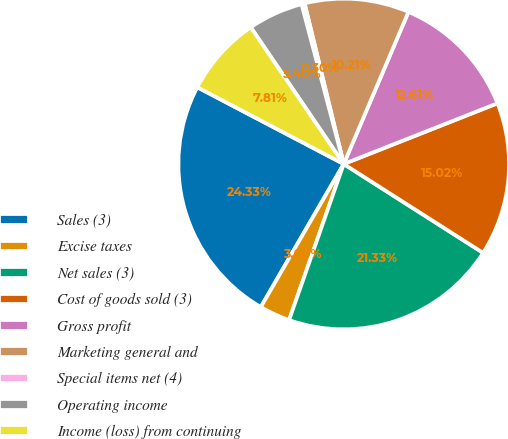<chart> <loc_0><loc_0><loc_500><loc_500><pie_chart><fcel>Sales (3)<fcel>Excise taxes<fcel>Net sales (3)<fcel>Cost of goods sold (3)<fcel>Gross profit<fcel>Marketing general and<fcel>Special items net (4)<fcel>Operating income<fcel>Income (loss) from continuing<nl><fcel>24.33%<fcel>3.0%<fcel>21.33%<fcel>15.02%<fcel>12.61%<fcel>10.21%<fcel>0.3%<fcel>5.4%<fcel>7.81%<nl></chart> 